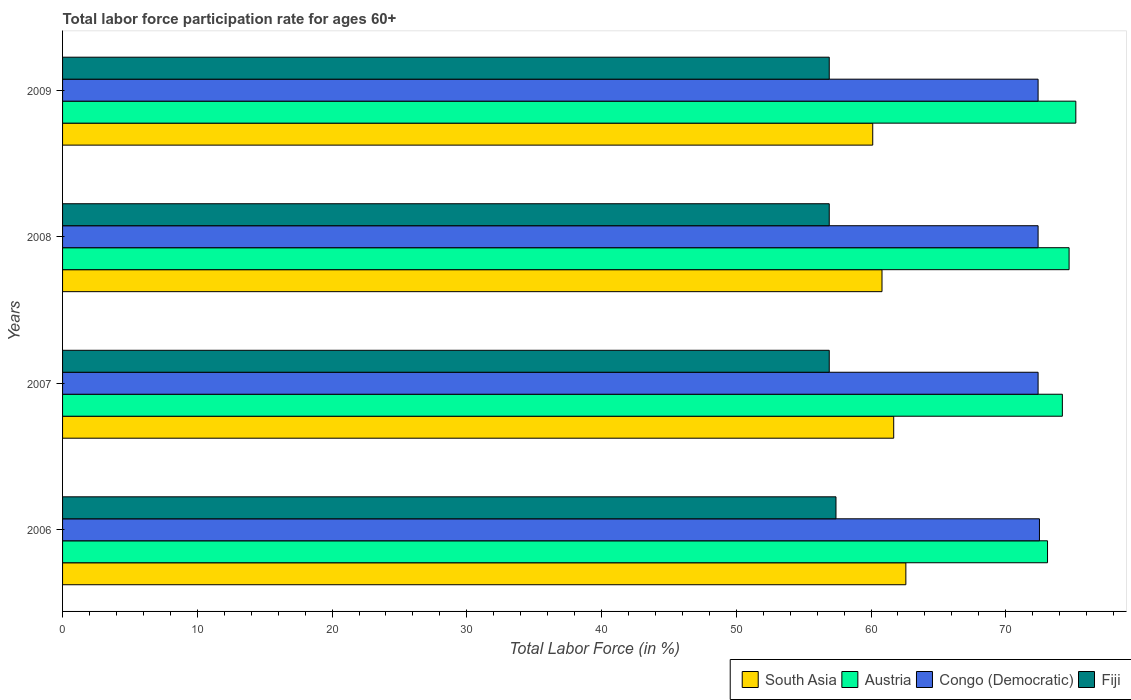How many different coloured bars are there?
Keep it short and to the point. 4. How many bars are there on the 4th tick from the top?
Offer a terse response. 4. How many bars are there on the 4th tick from the bottom?
Keep it short and to the point. 4. What is the label of the 3rd group of bars from the top?
Your answer should be compact. 2007. In how many cases, is the number of bars for a given year not equal to the number of legend labels?
Give a very brief answer. 0. What is the labor force participation rate in Austria in 2009?
Offer a very short reply. 75.2. Across all years, what is the maximum labor force participation rate in Congo (Democratic)?
Keep it short and to the point. 72.5. Across all years, what is the minimum labor force participation rate in Congo (Democratic)?
Your answer should be compact. 72.4. In which year was the labor force participation rate in Fiji minimum?
Ensure brevity in your answer.  2007. What is the total labor force participation rate in Austria in the graph?
Provide a short and direct response. 297.2. What is the difference between the labor force participation rate in Austria in 2007 and that in 2009?
Your response must be concise. -1. What is the difference between the labor force participation rate in South Asia in 2008 and the labor force participation rate in Congo (Democratic) in 2007?
Provide a short and direct response. -11.58. What is the average labor force participation rate in Congo (Democratic) per year?
Make the answer very short. 72.43. In the year 2008, what is the difference between the labor force participation rate in Congo (Democratic) and labor force participation rate in South Asia?
Ensure brevity in your answer.  11.58. What is the ratio of the labor force participation rate in Fiji in 2008 to that in 2009?
Your answer should be very brief. 1. Is the difference between the labor force participation rate in Congo (Democratic) in 2008 and 2009 greater than the difference between the labor force participation rate in South Asia in 2008 and 2009?
Make the answer very short. No. What is the difference between the highest and the second highest labor force participation rate in South Asia?
Offer a very short reply. 0.9. What is the difference between the highest and the lowest labor force participation rate in Fiji?
Provide a short and direct response. 0.5. In how many years, is the labor force participation rate in South Asia greater than the average labor force participation rate in South Asia taken over all years?
Provide a short and direct response. 2. What does the 4th bar from the top in 2009 represents?
Keep it short and to the point. South Asia. What does the 1st bar from the bottom in 2008 represents?
Offer a very short reply. South Asia. Is it the case that in every year, the sum of the labor force participation rate in Austria and labor force participation rate in Fiji is greater than the labor force participation rate in South Asia?
Provide a short and direct response. Yes. How many bars are there?
Your answer should be compact. 16. How many years are there in the graph?
Offer a terse response. 4. What is the difference between two consecutive major ticks on the X-axis?
Make the answer very short. 10. Are the values on the major ticks of X-axis written in scientific E-notation?
Your response must be concise. No. Does the graph contain any zero values?
Your response must be concise. No. How are the legend labels stacked?
Provide a short and direct response. Horizontal. What is the title of the graph?
Provide a short and direct response. Total labor force participation rate for ages 60+. Does "Zambia" appear as one of the legend labels in the graph?
Your response must be concise. No. What is the label or title of the X-axis?
Provide a succinct answer. Total Labor Force (in %). What is the Total Labor Force (in %) in South Asia in 2006?
Ensure brevity in your answer.  62.59. What is the Total Labor Force (in %) of Austria in 2006?
Give a very brief answer. 73.1. What is the Total Labor Force (in %) in Congo (Democratic) in 2006?
Offer a very short reply. 72.5. What is the Total Labor Force (in %) in Fiji in 2006?
Offer a very short reply. 57.4. What is the Total Labor Force (in %) in South Asia in 2007?
Make the answer very short. 61.68. What is the Total Labor Force (in %) in Austria in 2007?
Provide a short and direct response. 74.2. What is the Total Labor Force (in %) in Congo (Democratic) in 2007?
Keep it short and to the point. 72.4. What is the Total Labor Force (in %) in Fiji in 2007?
Provide a succinct answer. 56.9. What is the Total Labor Force (in %) in South Asia in 2008?
Provide a succinct answer. 60.82. What is the Total Labor Force (in %) of Austria in 2008?
Make the answer very short. 74.7. What is the Total Labor Force (in %) in Congo (Democratic) in 2008?
Offer a very short reply. 72.4. What is the Total Labor Force (in %) in Fiji in 2008?
Your answer should be very brief. 56.9. What is the Total Labor Force (in %) of South Asia in 2009?
Offer a very short reply. 60.13. What is the Total Labor Force (in %) in Austria in 2009?
Provide a succinct answer. 75.2. What is the Total Labor Force (in %) in Congo (Democratic) in 2009?
Offer a terse response. 72.4. What is the Total Labor Force (in %) in Fiji in 2009?
Make the answer very short. 56.9. Across all years, what is the maximum Total Labor Force (in %) in South Asia?
Keep it short and to the point. 62.59. Across all years, what is the maximum Total Labor Force (in %) in Austria?
Give a very brief answer. 75.2. Across all years, what is the maximum Total Labor Force (in %) in Congo (Democratic)?
Give a very brief answer. 72.5. Across all years, what is the maximum Total Labor Force (in %) in Fiji?
Ensure brevity in your answer.  57.4. Across all years, what is the minimum Total Labor Force (in %) of South Asia?
Keep it short and to the point. 60.13. Across all years, what is the minimum Total Labor Force (in %) in Austria?
Offer a terse response. 73.1. Across all years, what is the minimum Total Labor Force (in %) in Congo (Democratic)?
Keep it short and to the point. 72.4. Across all years, what is the minimum Total Labor Force (in %) in Fiji?
Provide a succinct answer. 56.9. What is the total Total Labor Force (in %) of South Asia in the graph?
Your answer should be very brief. 245.21. What is the total Total Labor Force (in %) of Austria in the graph?
Your response must be concise. 297.2. What is the total Total Labor Force (in %) in Congo (Democratic) in the graph?
Provide a succinct answer. 289.7. What is the total Total Labor Force (in %) of Fiji in the graph?
Make the answer very short. 228.1. What is the difference between the Total Labor Force (in %) in South Asia in 2006 and that in 2007?
Your answer should be very brief. 0.9. What is the difference between the Total Labor Force (in %) of Congo (Democratic) in 2006 and that in 2007?
Provide a short and direct response. 0.1. What is the difference between the Total Labor Force (in %) of Fiji in 2006 and that in 2007?
Ensure brevity in your answer.  0.5. What is the difference between the Total Labor Force (in %) of South Asia in 2006 and that in 2008?
Your response must be concise. 1.77. What is the difference between the Total Labor Force (in %) of Austria in 2006 and that in 2008?
Provide a succinct answer. -1.6. What is the difference between the Total Labor Force (in %) of Congo (Democratic) in 2006 and that in 2008?
Offer a terse response. 0.1. What is the difference between the Total Labor Force (in %) in South Asia in 2006 and that in 2009?
Your response must be concise. 2.46. What is the difference between the Total Labor Force (in %) in Congo (Democratic) in 2006 and that in 2009?
Your response must be concise. 0.1. What is the difference between the Total Labor Force (in %) of South Asia in 2007 and that in 2008?
Make the answer very short. 0.87. What is the difference between the Total Labor Force (in %) in South Asia in 2007 and that in 2009?
Ensure brevity in your answer.  1.56. What is the difference between the Total Labor Force (in %) in Austria in 2007 and that in 2009?
Make the answer very short. -1. What is the difference between the Total Labor Force (in %) of South Asia in 2008 and that in 2009?
Provide a succinct answer. 0.69. What is the difference between the Total Labor Force (in %) of Austria in 2008 and that in 2009?
Your answer should be very brief. -0.5. What is the difference between the Total Labor Force (in %) of Congo (Democratic) in 2008 and that in 2009?
Ensure brevity in your answer.  0. What is the difference between the Total Labor Force (in %) of South Asia in 2006 and the Total Labor Force (in %) of Austria in 2007?
Offer a very short reply. -11.61. What is the difference between the Total Labor Force (in %) in South Asia in 2006 and the Total Labor Force (in %) in Congo (Democratic) in 2007?
Provide a succinct answer. -9.81. What is the difference between the Total Labor Force (in %) in South Asia in 2006 and the Total Labor Force (in %) in Fiji in 2007?
Your answer should be compact. 5.69. What is the difference between the Total Labor Force (in %) of Austria in 2006 and the Total Labor Force (in %) of Congo (Democratic) in 2007?
Keep it short and to the point. 0.7. What is the difference between the Total Labor Force (in %) in Congo (Democratic) in 2006 and the Total Labor Force (in %) in Fiji in 2007?
Offer a very short reply. 15.6. What is the difference between the Total Labor Force (in %) in South Asia in 2006 and the Total Labor Force (in %) in Austria in 2008?
Your answer should be compact. -12.11. What is the difference between the Total Labor Force (in %) in South Asia in 2006 and the Total Labor Force (in %) in Congo (Democratic) in 2008?
Keep it short and to the point. -9.81. What is the difference between the Total Labor Force (in %) in South Asia in 2006 and the Total Labor Force (in %) in Fiji in 2008?
Your answer should be very brief. 5.69. What is the difference between the Total Labor Force (in %) of Austria in 2006 and the Total Labor Force (in %) of Congo (Democratic) in 2008?
Give a very brief answer. 0.7. What is the difference between the Total Labor Force (in %) of South Asia in 2006 and the Total Labor Force (in %) of Austria in 2009?
Provide a short and direct response. -12.61. What is the difference between the Total Labor Force (in %) of South Asia in 2006 and the Total Labor Force (in %) of Congo (Democratic) in 2009?
Offer a terse response. -9.81. What is the difference between the Total Labor Force (in %) in South Asia in 2006 and the Total Labor Force (in %) in Fiji in 2009?
Your response must be concise. 5.69. What is the difference between the Total Labor Force (in %) in South Asia in 2007 and the Total Labor Force (in %) in Austria in 2008?
Make the answer very short. -13.02. What is the difference between the Total Labor Force (in %) in South Asia in 2007 and the Total Labor Force (in %) in Congo (Democratic) in 2008?
Your answer should be compact. -10.72. What is the difference between the Total Labor Force (in %) in South Asia in 2007 and the Total Labor Force (in %) in Fiji in 2008?
Your answer should be very brief. 4.78. What is the difference between the Total Labor Force (in %) in Austria in 2007 and the Total Labor Force (in %) in Congo (Democratic) in 2008?
Ensure brevity in your answer.  1.8. What is the difference between the Total Labor Force (in %) in Congo (Democratic) in 2007 and the Total Labor Force (in %) in Fiji in 2008?
Keep it short and to the point. 15.5. What is the difference between the Total Labor Force (in %) of South Asia in 2007 and the Total Labor Force (in %) of Austria in 2009?
Make the answer very short. -13.52. What is the difference between the Total Labor Force (in %) in South Asia in 2007 and the Total Labor Force (in %) in Congo (Democratic) in 2009?
Ensure brevity in your answer.  -10.72. What is the difference between the Total Labor Force (in %) in South Asia in 2007 and the Total Labor Force (in %) in Fiji in 2009?
Offer a terse response. 4.78. What is the difference between the Total Labor Force (in %) in Austria in 2007 and the Total Labor Force (in %) in Fiji in 2009?
Provide a succinct answer. 17.3. What is the difference between the Total Labor Force (in %) of South Asia in 2008 and the Total Labor Force (in %) of Austria in 2009?
Give a very brief answer. -14.38. What is the difference between the Total Labor Force (in %) of South Asia in 2008 and the Total Labor Force (in %) of Congo (Democratic) in 2009?
Your response must be concise. -11.58. What is the difference between the Total Labor Force (in %) in South Asia in 2008 and the Total Labor Force (in %) in Fiji in 2009?
Give a very brief answer. 3.92. What is the difference between the Total Labor Force (in %) of Austria in 2008 and the Total Labor Force (in %) of Congo (Democratic) in 2009?
Your answer should be very brief. 2.3. What is the difference between the Total Labor Force (in %) in Austria in 2008 and the Total Labor Force (in %) in Fiji in 2009?
Give a very brief answer. 17.8. What is the average Total Labor Force (in %) of South Asia per year?
Make the answer very short. 61.3. What is the average Total Labor Force (in %) in Austria per year?
Offer a very short reply. 74.3. What is the average Total Labor Force (in %) in Congo (Democratic) per year?
Make the answer very short. 72.42. What is the average Total Labor Force (in %) in Fiji per year?
Provide a short and direct response. 57.02. In the year 2006, what is the difference between the Total Labor Force (in %) of South Asia and Total Labor Force (in %) of Austria?
Offer a very short reply. -10.51. In the year 2006, what is the difference between the Total Labor Force (in %) in South Asia and Total Labor Force (in %) in Congo (Democratic)?
Your answer should be very brief. -9.91. In the year 2006, what is the difference between the Total Labor Force (in %) of South Asia and Total Labor Force (in %) of Fiji?
Give a very brief answer. 5.19. In the year 2006, what is the difference between the Total Labor Force (in %) in Austria and Total Labor Force (in %) in Congo (Democratic)?
Your answer should be very brief. 0.6. In the year 2006, what is the difference between the Total Labor Force (in %) in Congo (Democratic) and Total Labor Force (in %) in Fiji?
Your answer should be compact. 15.1. In the year 2007, what is the difference between the Total Labor Force (in %) of South Asia and Total Labor Force (in %) of Austria?
Provide a succinct answer. -12.52. In the year 2007, what is the difference between the Total Labor Force (in %) of South Asia and Total Labor Force (in %) of Congo (Democratic)?
Offer a very short reply. -10.72. In the year 2007, what is the difference between the Total Labor Force (in %) in South Asia and Total Labor Force (in %) in Fiji?
Provide a succinct answer. 4.78. In the year 2007, what is the difference between the Total Labor Force (in %) of Austria and Total Labor Force (in %) of Fiji?
Your response must be concise. 17.3. In the year 2007, what is the difference between the Total Labor Force (in %) in Congo (Democratic) and Total Labor Force (in %) in Fiji?
Offer a very short reply. 15.5. In the year 2008, what is the difference between the Total Labor Force (in %) of South Asia and Total Labor Force (in %) of Austria?
Give a very brief answer. -13.88. In the year 2008, what is the difference between the Total Labor Force (in %) in South Asia and Total Labor Force (in %) in Congo (Democratic)?
Ensure brevity in your answer.  -11.58. In the year 2008, what is the difference between the Total Labor Force (in %) in South Asia and Total Labor Force (in %) in Fiji?
Your answer should be very brief. 3.92. In the year 2008, what is the difference between the Total Labor Force (in %) of Austria and Total Labor Force (in %) of Congo (Democratic)?
Your response must be concise. 2.3. In the year 2008, what is the difference between the Total Labor Force (in %) in Congo (Democratic) and Total Labor Force (in %) in Fiji?
Offer a terse response. 15.5. In the year 2009, what is the difference between the Total Labor Force (in %) of South Asia and Total Labor Force (in %) of Austria?
Offer a terse response. -15.07. In the year 2009, what is the difference between the Total Labor Force (in %) in South Asia and Total Labor Force (in %) in Congo (Democratic)?
Your response must be concise. -12.27. In the year 2009, what is the difference between the Total Labor Force (in %) of South Asia and Total Labor Force (in %) of Fiji?
Offer a terse response. 3.23. In the year 2009, what is the difference between the Total Labor Force (in %) in Congo (Democratic) and Total Labor Force (in %) in Fiji?
Provide a short and direct response. 15.5. What is the ratio of the Total Labor Force (in %) in South Asia in 2006 to that in 2007?
Your answer should be very brief. 1.01. What is the ratio of the Total Labor Force (in %) of Austria in 2006 to that in 2007?
Your answer should be very brief. 0.99. What is the ratio of the Total Labor Force (in %) in Congo (Democratic) in 2006 to that in 2007?
Make the answer very short. 1. What is the ratio of the Total Labor Force (in %) of Fiji in 2006 to that in 2007?
Keep it short and to the point. 1.01. What is the ratio of the Total Labor Force (in %) of South Asia in 2006 to that in 2008?
Your answer should be very brief. 1.03. What is the ratio of the Total Labor Force (in %) in Austria in 2006 to that in 2008?
Keep it short and to the point. 0.98. What is the ratio of the Total Labor Force (in %) in Fiji in 2006 to that in 2008?
Provide a succinct answer. 1.01. What is the ratio of the Total Labor Force (in %) of South Asia in 2006 to that in 2009?
Your response must be concise. 1.04. What is the ratio of the Total Labor Force (in %) in Austria in 2006 to that in 2009?
Your response must be concise. 0.97. What is the ratio of the Total Labor Force (in %) in Congo (Democratic) in 2006 to that in 2009?
Offer a very short reply. 1. What is the ratio of the Total Labor Force (in %) of Fiji in 2006 to that in 2009?
Ensure brevity in your answer.  1.01. What is the ratio of the Total Labor Force (in %) of South Asia in 2007 to that in 2008?
Keep it short and to the point. 1.01. What is the ratio of the Total Labor Force (in %) in Austria in 2007 to that in 2008?
Offer a very short reply. 0.99. What is the ratio of the Total Labor Force (in %) in Congo (Democratic) in 2007 to that in 2008?
Your answer should be very brief. 1. What is the ratio of the Total Labor Force (in %) of South Asia in 2007 to that in 2009?
Make the answer very short. 1.03. What is the ratio of the Total Labor Force (in %) in Austria in 2007 to that in 2009?
Offer a very short reply. 0.99. What is the ratio of the Total Labor Force (in %) in Fiji in 2007 to that in 2009?
Provide a short and direct response. 1. What is the ratio of the Total Labor Force (in %) in South Asia in 2008 to that in 2009?
Offer a terse response. 1.01. What is the ratio of the Total Labor Force (in %) in Austria in 2008 to that in 2009?
Provide a short and direct response. 0.99. What is the ratio of the Total Labor Force (in %) in Congo (Democratic) in 2008 to that in 2009?
Your answer should be very brief. 1. What is the difference between the highest and the second highest Total Labor Force (in %) of South Asia?
Keep it short and to the point. 0.9. What is the difference between the highest and the second highest Total Labor Force (in %) of Austria?
Your answer should be compact. 0.5. What is the difference between the highest and the lowest Total Labor Force (in %) in South Asia?
Provide a succinct answer. 2.46. What is the difference between the highest and the lowest Total Labor Force (in %) in Congo (Democratic)?
Keep it short and to the point. 0.1. What is the difference between the highest and the lowest Total Labor Force (in %) of Fiji?
Your answer should be very brief. 0.5. 